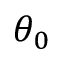<formula> <loc_0><loc_0><loc_500><loc_500>\theta _ { 0 }</formula> 